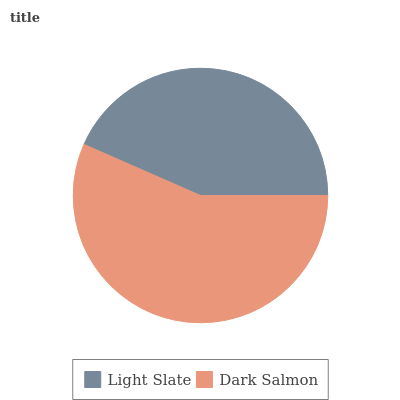Is Light Slate the minimum?
Answer yes or no. Yes. Is Dark Salmon the maximum?
Answer yes or no. Yes. Is Dark Salmon the minimum?
Answer yes or no. No. Is Dark Salmon greater than Light Slate?
Answer yes or no. Yes. Is Light Slate less than Dark Salmon?
Answer yes or no. Yes. Is Light Slate greater than Dark Salmon?
Answer yes or no. No. Is Dark Salmon less than Light Slate?
Answer yes or no. No. Is Dark Salmon the high median?
Answer yes or no. Yes. Is Light Slate the low median?
Answer yes or no. Yes. Is Light Slate the high median?
Answer yes or no. No. Is Dark Salmon the low median?
Answer yes or no. No. 